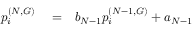Convert formula to latex. <formula><loc_0><loc_0><loc_500><loc_500>\begin{array} { r l r } { p _ { i } ^ { ( N , G ) } } & = } & { b _ { N - 1 } p _ { i } ^ { ( N - 1 , G ) } + a _ { N - 1 } } \end{array}</formula> 